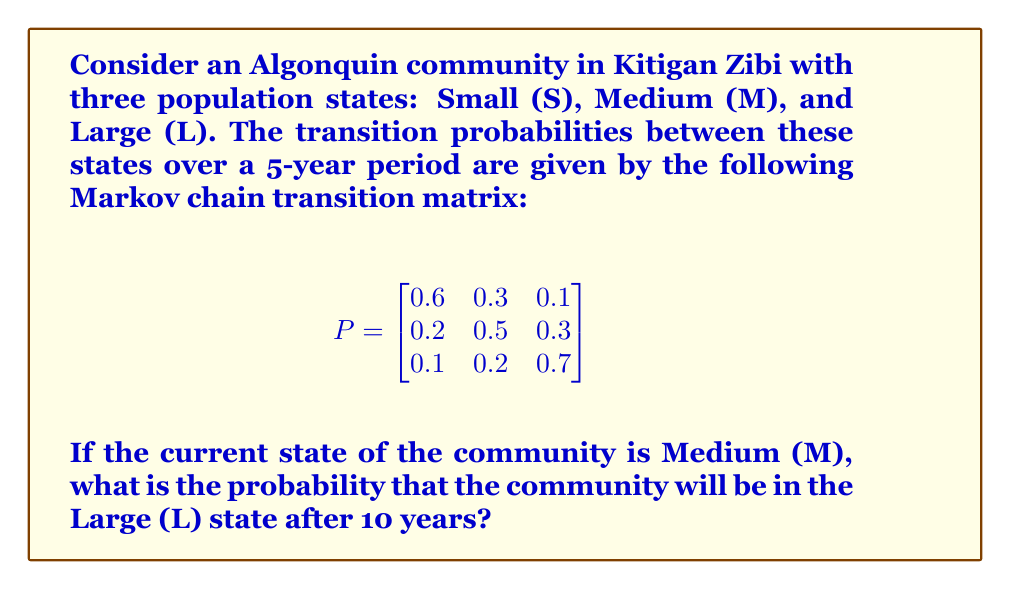Provide a solution to this math problem. To solve this problem, we need to follow these steps:

1) First, we need to calculate $P^2$, which represents the transition probabilities over a 10-year period (since each transition represents 5 years).

2) We can calculate $P^2$ by multiplying P by itself:

   $$P^2 = P \times P = \begin{bmatrix}
   0.6 & 0.3 & 0.1 \\
   0.2 & 0.5 & 0.3 \\
   0.1 & 0.2 & 0.7
   \end{bmatrix} \times \begin{bmatrix}
   0.6 & 0.3 & 0.1 \\
   0.2 & 0.5 & 0.3 \\
   0.1 & 0.2 & 0.7
   \end{bmatrix}$$

3) Performing the matrix multiplication:

   $$P^2 = \begin{bmatrix}
   0.41 & 0.36 & 0.23 \\
   0.25 & 0.41 & 0.34 \\
   0.17 & 0.28 & 0.55
   \end{bmatrix}$$

4) The question asks for the probability of transitioning from Medium (M) to Large (L) after 10 years. This corresponds to the element in the second row (M) and third column (L) of $P^2$.

5) From the $P^2$ matrix, we can see that this probability is 0.34.
Answer: 0.34 